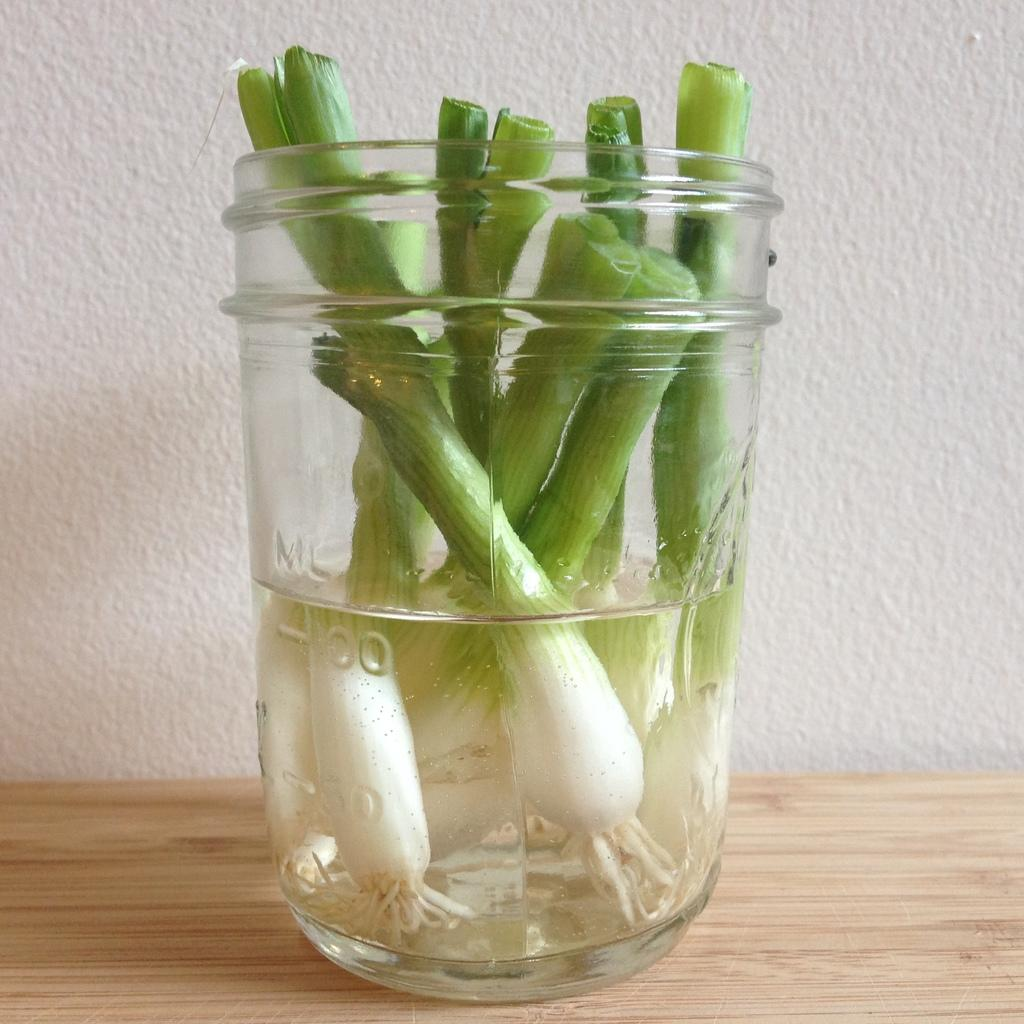What type of surface is visible in the image? There is a wooden surface in the image. What is placed on the wooden surface? There is a jar on the wooden surface. What is inside the jar? The jar contains water and spring onions. What can be seen in the background of the image? There is a white wall in the background of the image. What type of worm can be seen crawling on the spring onions in the image? There are no worms present in the image; the jar contains water and spring onions. 